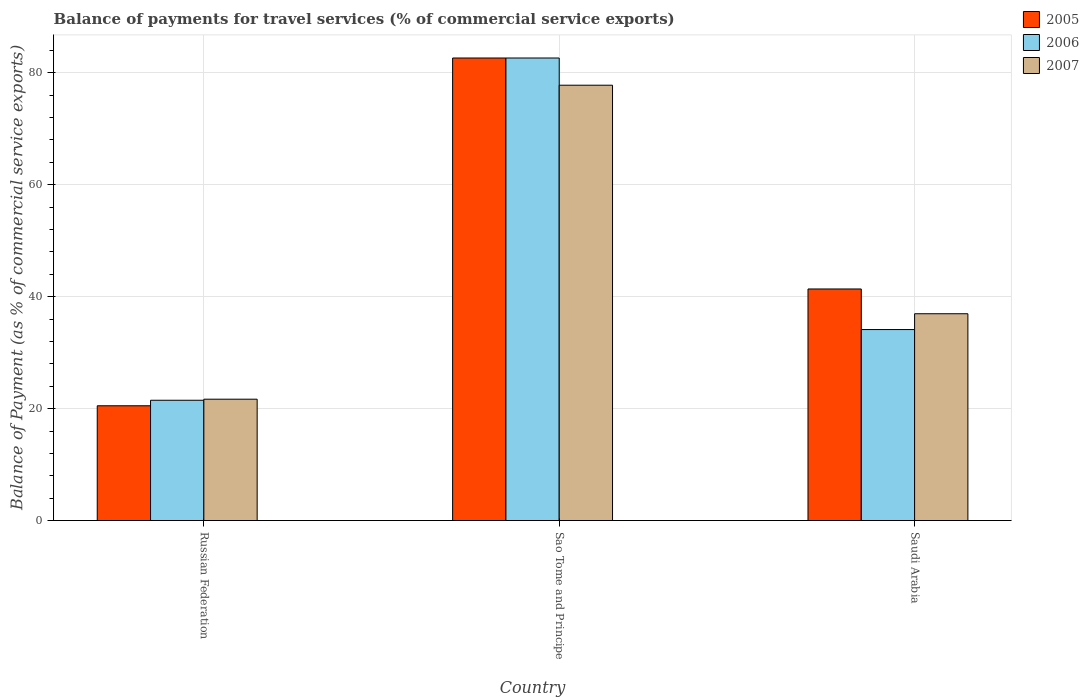How many different coloured bars are there?
Your answer should be compact. 3. How many groups of bars are there?
Your response must be concise. 3. Are the number of bars on each tick of the X-axis equal?
Give a very brief answer. Yes. How many bars are there on the 3rd tick from the right?
Give a very brief answer. 3. What is the label of the 2nd group of bars from the left?
Ensure brevity in your answer.  Sao Tome and Principe. In how many cases, is the number of bars for a given country not equal to the number of legend labels?
Offer a terse response. 0. What is the balance of payments for travel services in 2007 in Sao Tome and Principe?
Give a very brief answer. 77.78. Across all countries, what is the maximum balance of payments for travel services in 2006?
Provide a succinct answer. 82.64. Across all countries, what is the minimum balance of payments for travel services in 2006?
Your response must be concise. 21.5. In which country was the balance of payments for travel services in 2006 maximum?
Offer a very short reply. Sao Tome and Principe. In which country was the balance of payments for travel services in 2007 minimum?
Keep it short and to the point. Russian Federation. What is the total balance of payments for travel services in 2006 in the graph?
Ensure brevity in your answer.  138.27. What is the difference between the balance of payments for travel services in 2006 in Russian Federation and that in Sao Tome and Principe?
Your answer should be compact. -61.15. What is the difference between the balance of payments for travel services in 2006 in Saudi Arabia and the balance of payments for travel services in 2007 in Sao Tome and Principe?
Provide a succinct answer. -43.66. What is the average balance of payments for travel services in 2007 per country?
Keep it short and to the point. 45.47. What is the difference between the balance of payments for travel services of/in 2007 and balance of payments for travel services of/in 2006 in Sao Tome and Principe?
Provide a short and direct response. -4.86. In how many countries, is the balance of payments for travel services in 2006 greater than 32 %?
Your response must be concise. 2. What is the ratio of the balance of payments for travel services in 2007 in Sao Tome and Principe to that in Saudi Arabia?
Your answer should be compact. 2.1. Is the difference between the balance of payments for travel services in 2007 in Sao Tome and Principe and Saudi Arabia greater than the difference between the balance of payments for travel services in 2006 in Sao Tome and Principe and Saudi Arabia?
Make the answer very short. No. What is the difference between the highest and the second highest balance of payments for travel services in 2007?
Your answer should be compact. -15.27. What is the difference between the highest and the lowest balance of payments for travel services in 2006?
Make the answer very short. 61.15. What does the 3rd bar from the right in Saudi Arabia represents?
Provide a succinct answer. 2005. Is it the case that in every country, the sum of the balance of payments for travel services in 2005 and balance of payments for travel services in 2007 is greater than the balance of payments for travel services in 2006?
Your answer should be very brief. Yes. How many bars are there?
Your answer should be compact. 9. Are the values on the major ticks of Y-axis written in scientific E-notation?
Make the answer very short. No. Does the graph contain grids?
Provide a succinct answer. Yes. Where does the legend appear in the graph?
Provide a short and direct response. Top right. How many legend labels are there?
Ensure brevity in your answer.  3. How are the legend labels stacked?
Offer a very short reply. Vertical. What is the title of the graph?
Your response must be concise. Balance of payments for travel services (% of commercial service exports). What is the label or title of the X-axis?
Keep it short and to the point. Country. What is the label or title of the Y-axis?
Keep it short and to the point. Balance of Payment (as % of commercial service exports). What is the Balance of Payment (as % of commercial service exports) of 2005 in Russian Federation?
Offer a terse response. 20.51. What is the Balance of Payment (as % of commercial service exports) in 2006 in Russian Federation?
Provide a short and direct response. 21.5. What is the Balance of Payment (as % of commercial service exports) of 2007 in Russian Federation?
Offer a very short reply. 21.69. What is the Balance of Payment (as % of commercial service exports) of 2005 in Sao Tome and Principe?
Give a very brief answer. 82.64. What is the Balance of Payment (as % of commercial service exports) of 2006 in Sao Tome and Principe?
Keep it short and to the point. 82.64. What is the Balance of Payment (as % of commercial service exports) of 2007 in Sao Tome and Principe?
Your answer should be very brief. 77.78. What is the Balance of Payment (as % of commercial service exports) in 2005 in Saudi Arabia?
Provide a succinct answer. 41.38. What is the Balance of Payment (as % of commercial service exports) in 2006 in Saudi Arabia?
Keep it short and to the point. 34.13. What is the Balance of Payment (as % of commercial service exports) of 2007 in Saudi Arabia?
Keep it short and to the point. 36.95. Across all countries, what is the maximum Balance of Payment (as % of commercial service exports) of 2005?
Provide a short and direct response. 82.64. Across all countries, what is the maximum Balance of Payment (as % of commercial service exports) in 2006?
Make the answer very short. 82.64. Across all countries, what is the maximum Balance of Payment (as % of commercial service exports) in 2007?
Your answer should be compact. 77.78. Across all countries, what is the minimum Balance of Payment (as % of commercial service exports) of 2005?
Keep it short and to the point. 20.51. Across all countries, what is the minimum Balance of Payment (as % of commercial service exports) of 2006?
Give a very brief answer. 21.5. Across all countries, what is the minimum Balance of Payment (as % of commercial service exports) in 2007?
Your answer should be compact. 21.69. What is the total Balance of Payment (as % of commercial service exports) of 2005 in the graph?
Offer a very short reply. 144.53. What is the total Balance of Payment (as % of commercial service exports) in 2006 in the graph?
Offer a terse response. 138.27. What is the total Balance of Payment (as % of commercial service exports) in 2007 in the graph?
Your answer should be compact. 136.42. What is the difference between the Balance of Payment (as % of commercial service exports) in 2005 in Russian Federation and that in Sao Tome and Principe?
Provide a succinct answer. -62.13. What is the difference between the Balance of Payment (as % of commercial service exports) of 2006 in Russian Federation and that in Sao Tome and Principe?
Your answer should be very brief. -61.15. What is the difference between the Balance of Payment (as % of commercial service exports) in 2007 in Russian Federation and that in Sao Tome and Principe?
Offer a terse response. -56.1. What is the difference between the Balance of Payment (as % of commercial service exports) in 2005 in Russian Federation and that in Saudi Arabia?
Your answer should be very brief. -20.87. What is the difference between the Balance of Payment (as % of commercial service exports) in 2006 in Russian Federation and that in Saudi Arabia?
Your response must be concise. -12.63. What is the difference between the Balance of Payment (as % of commercial service exports) in 2007 in Russian Federation and that in Saudi Arabia?
Keep it short and to the point. -15.27. What is the difference between the Balance of Payment (as % of commercial service exports) of 2005 in Sao Tome and Principe and that in Saudi Arabia?
Your answer should be very brief. 41.26. What is the difference between the Balance of Payment (as % of commercial service exports) in 2006 in Sao Tome and Principe and that in Saudi Arabia?
Keep it short and to the point. 48.52. What is the difference between the Balance of Payment (as % of commercial service exports) in 2007 in Sao Tome and Principe and that in Saudi Arabia?
Provide a succinct answer. 40.83. What is the difference between the Balance of Payment (as % of commercial service exports) of 2005 in Russian Federation and the Balance of Payment (as % of commercial service exports) of 2006 in Sao Tome and Principe?
Give a very brief answer. -62.13. What is the difference between the Balance of Payment (as % of commercial service exports) of 2005 in Russian Federation and the Balance of Payment (as % of commercial service exports) of 2007 in Sao Tome and Principe?
Give a very brief answer. -57.27. What is the difference between the Balance of Payment (as % of commercial service exports) of 2006 in Russian Federation and the Balance of Payment (as % of commercial service exports) of 2007 in Sao Tome and Principe?
Give a very brief answer. -56.29. What is the difference between the Balance of Payment (as % of commercial service exports) in 2005 in Russian Federation and the Balance of Payment (as % of commercial service exports) in 2006 in Saudi Arabia?
Your response must be concise. -13.61. What is the difference between the Balance of Payment (as % of commercial service exports) in 2005 in Russian Federation and the Balance of Payment (as % of commercial service exports) in 2007 in Saudi Arabia?
Your answer should be compact. -16.44. What is the difference between the Balance of Payment (as % of commercial service exports) of 2006 in Russian Federation and the Balance of Payment (as % of commercial service exports) of 2007 in Saudi Arabia?
Give a very brief answer. -15.45. What is the difference between the Balance of Payment (as % of commercial service exports) of 2005 in Sao Tome and Principe and the Balance of Payment (as % of commercial service exports) of 2006 in Saudi Arabia?
Give a very brief answer. 48.52. What is the difference between the Balance of Payment (as % of commercial service exports) in 2005 in Sao Tome and Principe and the Balance of Payment (as % of commercial service exports) in 2007 in Saudi Arabia?
Offer a very short reply. 45.69. What is the difference between the Balance of Payment (as % of commercial service exports) in 2006 in Sao Tome and Principe and the Balance of Payment (as % of commercial service exports) in 2007 in Saudi Arabia?
Ensure brevity in your answer.  45.69. What is the average Balance of Payment (as % of commercial service exports) in 2005 per country?
Provide a succinct answer. 48.18. What is the average Balance of Payment (as % of commercial service exports) of 2006 per country?
Provide a succinct answer. 46.09. What is the average Balance of Payment (as % of commercial service exports) in 2007 per country?
Ensure brevity in your answer.  45.47. What is the difference between the Balance of Payment (as % of commercial service exports) of 2005 and Balance of Payment (as % of commercial service exports) of 2006 in Russian Federation?
Your answer should be compact. -0.99. What is the difference between the Balance of Payment (as % of commercial service exports) of 2005 and Balance of Payment (as % of commercial service exports) of 2007 in Russian Federation?
Offer a terse response. -1.17. What is the difference between the Balance of Payment (as % of commercial service exports) of 2006 and Balance of Payment (as % of commercial service exports) of 2007 in Russian Federation?
Your response must be concise. -0.19. What is the difference between the Balance of Payment (as % of commercial service exports) in 2005 and Balance of Payment (as % of commercial service exports) in 2007 in Sao Tome and Principe?
Ensure brevity in your answer.  4.86. What is the difference between the Balance of Payment (as % of commercial service exports) in 2006 and Balance of Payment (as % of commercial service exports) in 2007 in Sao Tome and Principe?
Your answer should be compact. 4.86. What is the difference between the Balance of Payment (as % of commercial service exports) in 2005 and Balance of Payment (as % of commercial service exports) in 2006 in Saudi Arabia?
Offer a terse response. 7.25. What is the difference between the Balance of Payment (as % of commercial service exports) of 2005 and Balance of Payment (as % of commercial service exports) of 2007 in Saudi Arabia?
Provide a succinct answer. 4.43. What is the difference between the Balance of Payment (as % of commercial service exports) in 2006 and Balance of Payment (as % of commercial service exports) in 2007 in Saudi Arabia?
Offer a very short reply. -2.82. What is the ratio of the Balance of Payment (as % of commercial service exports) in 2005 in Russian Federation to that in Sao Tome and Principe?
Your answer should be very brief. 0.25. What is the ratio of the Balance of Payment (as % of commercial service exports) in 2006 in Russian Federation to that in Sao Tome and Principe?
Provide a short and direct response. 0.26. What is the ratio of the Balance of Payment (as % of commercial service exports) of 2007 in Russian Federation to that in Sao Tome and Principe?
Ensure brevity in your answer.  0.28. What is the ratio of the Balance of Payment (as % of commercial service exports) in 2005 in Russian Federation to that in Saudi Arabia?
Provide a succinct answer. 0.5. What is the ratio of the Balance of Payment (as % of commercial service exports) of 2006 in Russian Federation to that in Saudi Arabia?
Make the answer very short. 0.63. What is the ratio of the Balance of Payment (as % of commercial service exports) in 2007 in Russian Federation to that in Saudi Arabia?
Your answer should be very brief. 0.59. What is the ratio of the Balance of Payment (as % of commercial service exports) of 2005 in Sao Tome and Principe to that in Saudi Arabia?
Your answer should be very brief. 2. What is the ratio of the Balance of Payment (as % of commercial service exports) in 2006 in Sao Tome and Principe to that in Saudi Arabia?
Your answer should be compact. 2.42. What is the ratio of the Balance of Payment (as % of commercial service exports) of 2007 in Sao Tome and Principe to that in Saudi Arabia?
Provide a short and direct response. 2.1. What is the difference between the highest and the second highest Balance of Payment (as % of commercial service exports) in 2005?
Provide a short and direct response. 41.26. What is the difference between the highest and the second highest Balance of Payment (as % of commercial service exports) in 2006?
Ensure brevity in your answer.  48.52. What is the difference between the highest and the second highest Balance of Payment (as % of commercial service exports) of 2007?
Keep it short and to the point. 40.83. What is the difference between the highest and the lowest Balance of Payment (as % of commercial service exports) of 2005?
Ensure brevity in your answer.  62.13. What is the difference between the highest and the lowest Balance of Payment (as % of commercial service exports) of 2006?
Your response must be concise. 61.15. What is the difference between the highest and the lowest Balance of Payment (as % of commercial service exports) in 2007?
Provide a succinct answer. 56.1. 